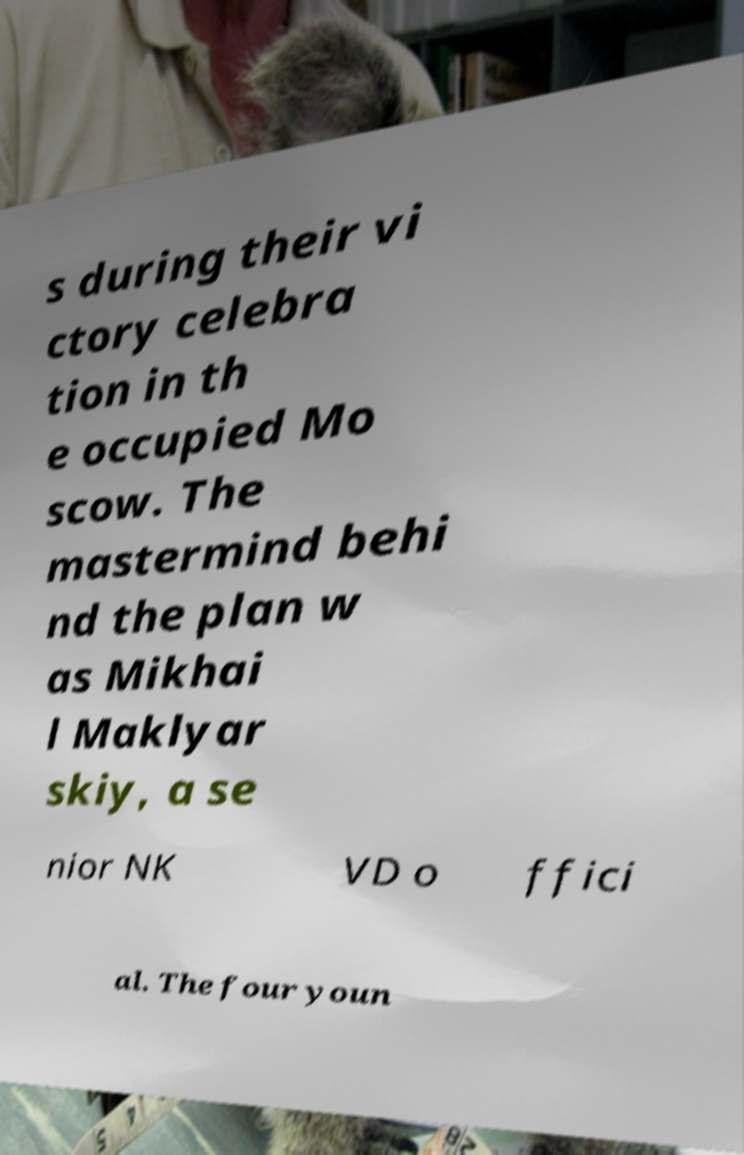What messages or text are displayed in this image? I need them in a readable, typed format. s during their vi ctory celebra tion in th e occupied Mo scow. The mastermind behi nd the plan w as Mikhai l Maklyar skiy, a se nior NK VD o ffici al. The four youn 